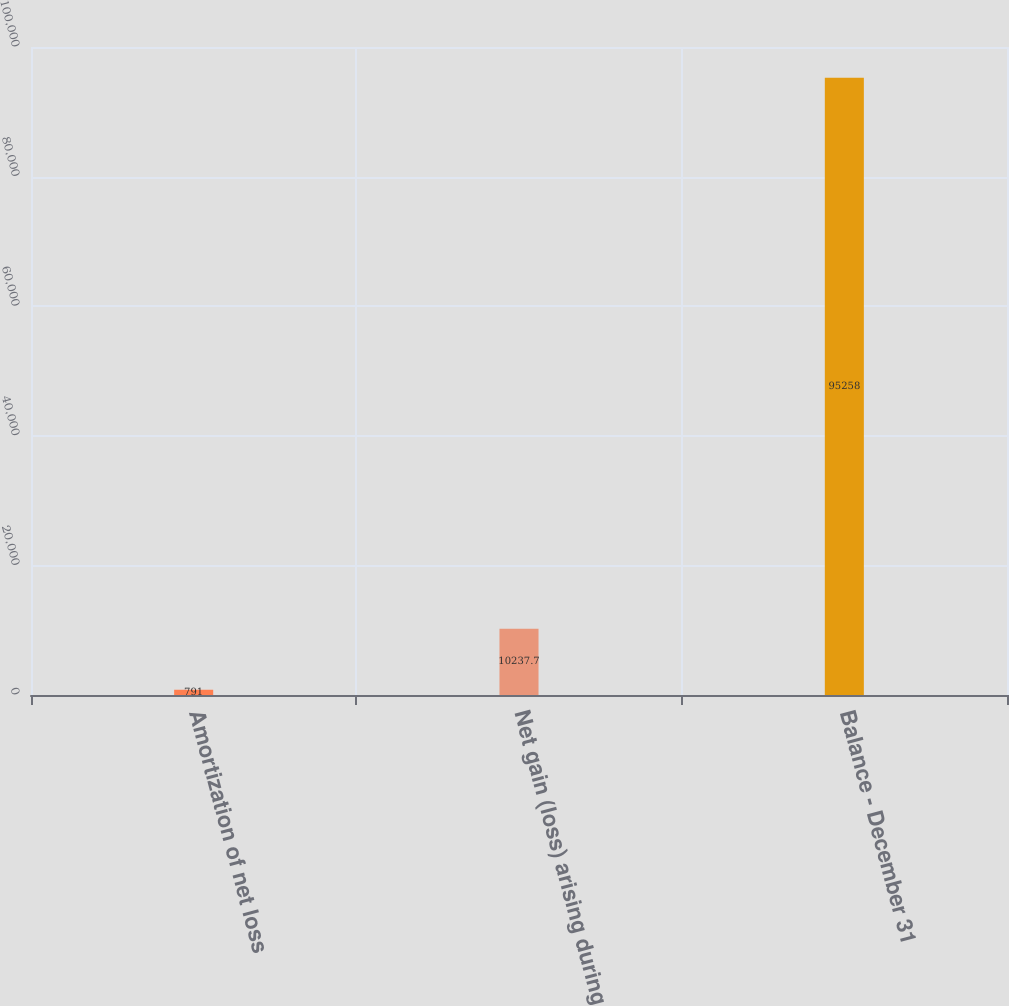Convert chart to OTSL. <chart><loc_0><loc_0><loc_500><loc_500><bar_chart><fcel>Amortization of net loss<fcel>Net gain (loss) arising during<fcel>Balance - December 31<nl><fcel>791<fcel>10237.7<fcel>95258<nl></chart> 